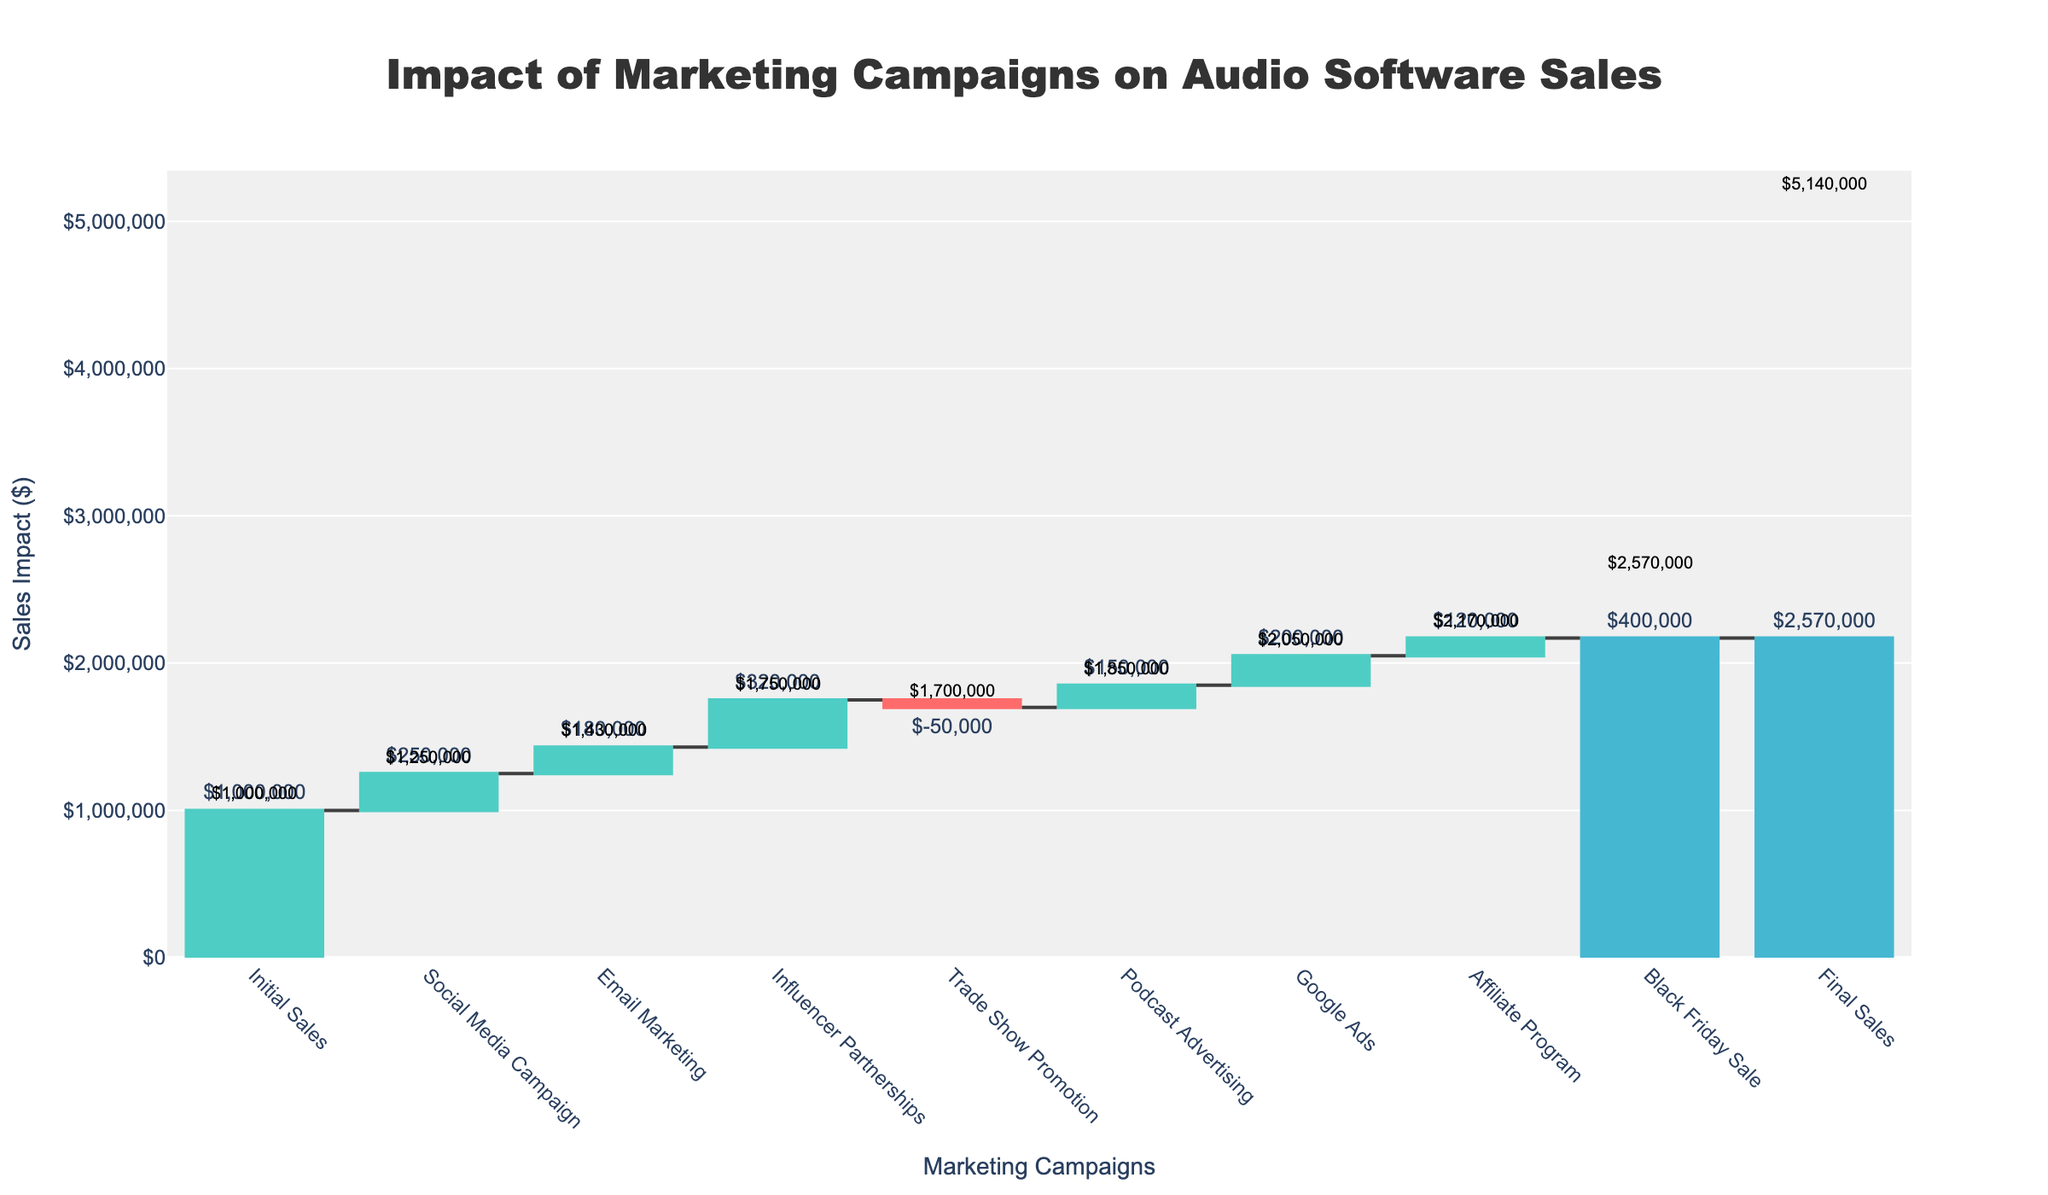What's the title of the chart? The title is usually displayed at the top of the chart. In this case, it reads "Impact of Marketing Campaigns on Audio Software Sales".
Answer: Impact of Marketing Campaigns on Audio Software Sales How much did the social media campaign increase sales by? The value from the "Social Media Campaign" is extracted from the visualized bar labeled "Social Media Campaign".
Answer: $250,000 What are the final sales? Check the cumulative value at the end of the waterfall chart which is listed under "Final Sales".
Answer: $2,570,000 What's the cumulative sales after the influencer partnerships? Find the bar labeled "Influencer Partnerships" and look for its cumulative annotation right above this section of the chart.
Answer: $1,750,000 What marketing campaign had a negative impact on sales? Identify the section where the bar goes downward. In this case, the label reads "Trade Show Promotion".
Answer: Trade Show Promotion How much did email marketing contribute to the total sales? Look at the value represented by the "Email Marketing" bar which increases the sales in the waterfall chart.
Answer: $180,000 Which campaign had the highest impact on sales? Compare the heights of all the increasing bars, the label with the highest value is "Black Friday Sale".
Answer: Black Friday Sale What was the combined sales impact of social media and email marketing? Add the individual contributions of the "Social Media Campaign" and "Email Marketing" bars: $250,000 + $180,000 = $430,000.
Answer: $430,000 By how much did the Google Ads increase the sales? Identify the segment labeled "Google Ads" and refer to its value indicated in the chart bars.
Answer: $200,000 What is the cumulative sales after all marketing campaigns excluding the final sales? Sum up all contributions including both positive and negative, then add to the initial sales: $1,000,000 + 250,000 + 180,000 + 320,000 - 50,000 + 150,000 + 200,000 + 120,000 + 400,000 = $2,570,000.
Answer: $2,570,000 